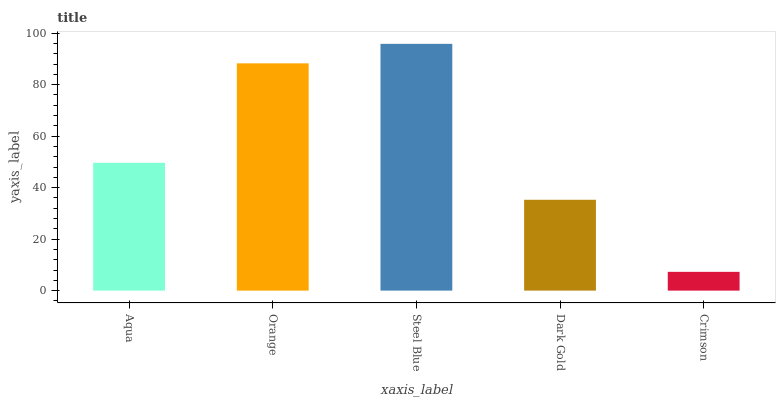Is Crimson the minimum?
Answer yes or no. Yes. Is Steel Blue the maximum?
Answer yes or no. Yes. Is Orange the minimum?
Answer yes or no. No. Is Orange the maximum?
Answer yes or no. No. Is Orange greater than Aqua?
Answer yes or no. Yes. Is Aqua less than Orange?
Answer yes or no. Yes. Is Aqua greater than Orange?
Answer yes or no. No. Is Orange less than Aqua?
Answer yes or no. No. Is Aqua the high median?
Answer yes or no. Yes. Is Aqua the low median?
Answer yes or no. Yes. Is Orange the high median?
Answer yes or no. No. Is Dark Gold the low median?
Answer yes or no. No. 